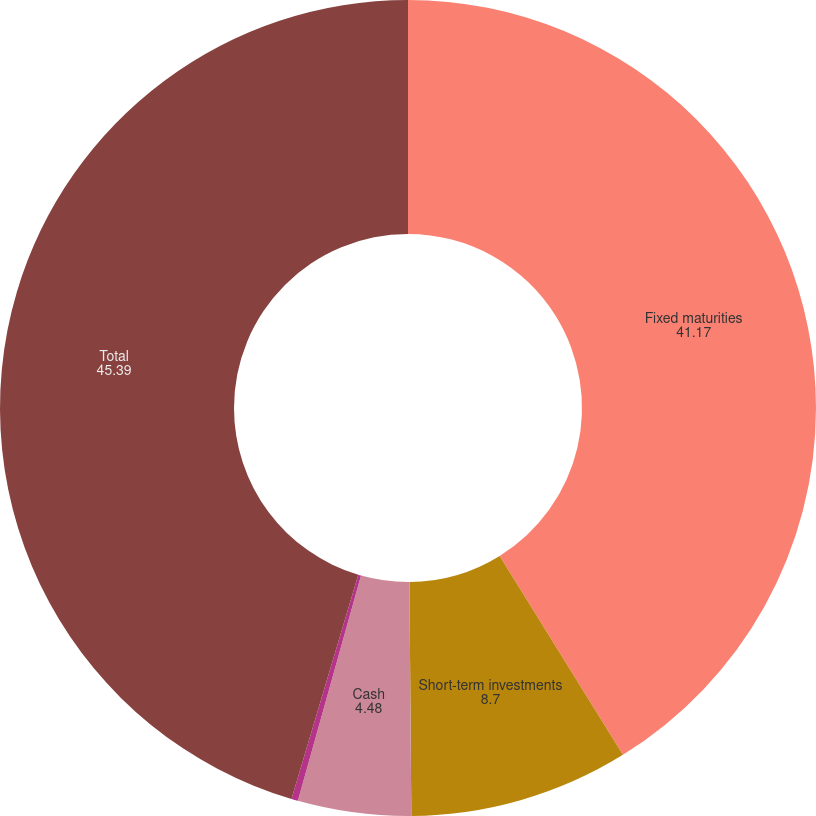<chart> <loc_0><loc_0><loc_500><loc_500><pie_chart><fcel>Fixed maturities<fcel>Short-term investments<fcel>Cash<fcel>Less Derivative collateral<fcel>Total<nl><fcel>41.17%<fcel>8.7%<fcel>4.48%<fcel>0.26%<fcel>45.39%<nl></chart> 